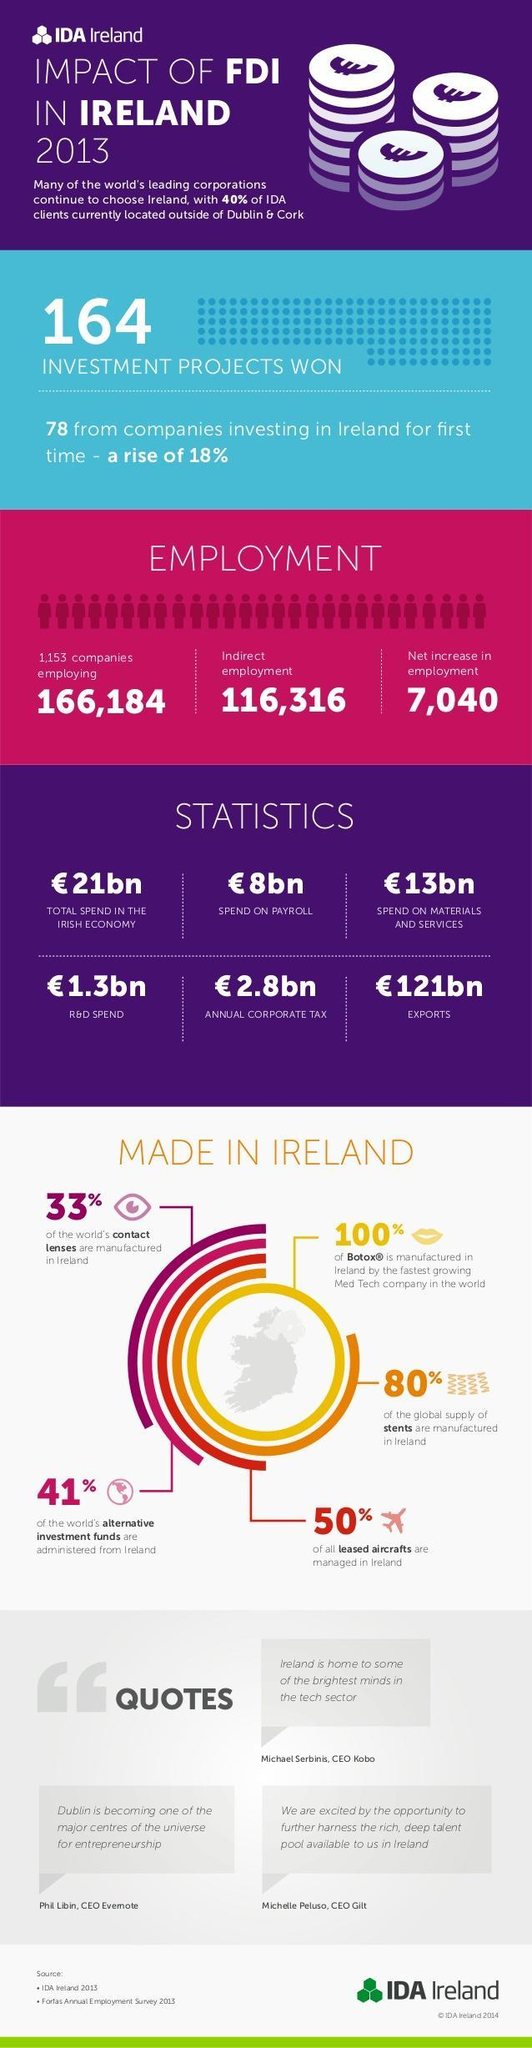What is the net increase in the employment of Ireland due to the impact of FDI in 2013?
Answer the question with a short phrase. 7,040 How much does Ireland spend (in euros) on Research & Development in 2013? 1.3bn What is the export value (in euros) of Ireland in 2013? 121bn 